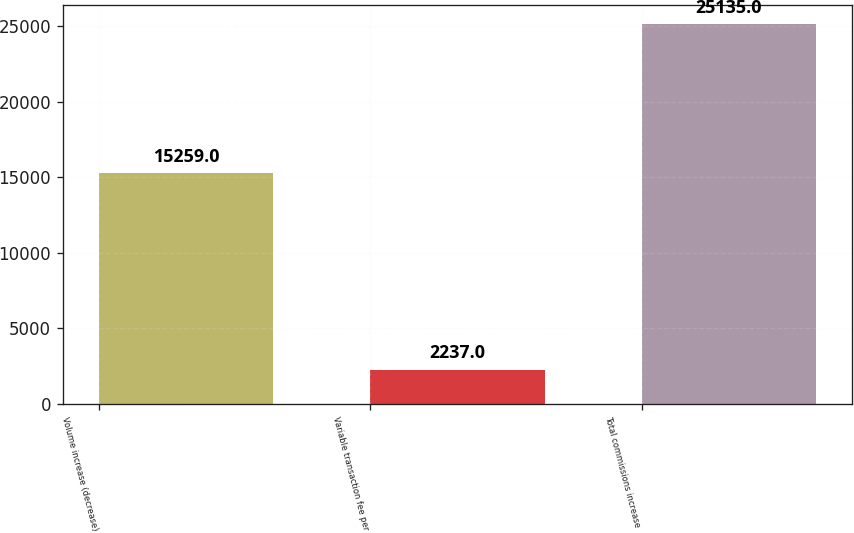Convert chart to OTSL. <chart><loc_0><loc_0><loc_500><loc_500><bar_chart><fcel>Volume increase (decrease)<fcel>Variable transaction fee per<fcel>Total commissions increase<nl><fcel>15259<fcel>2237<fcel>25135<nl></chart> 